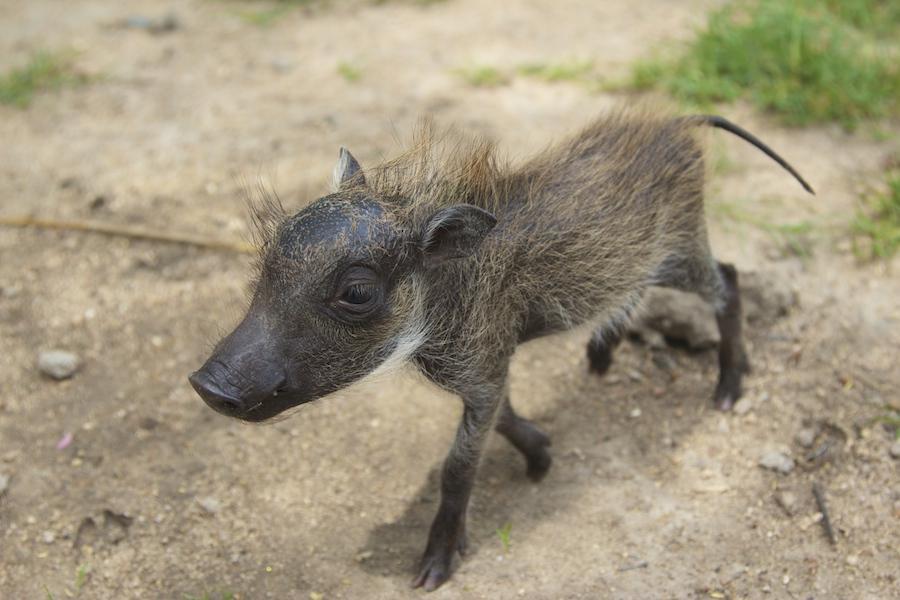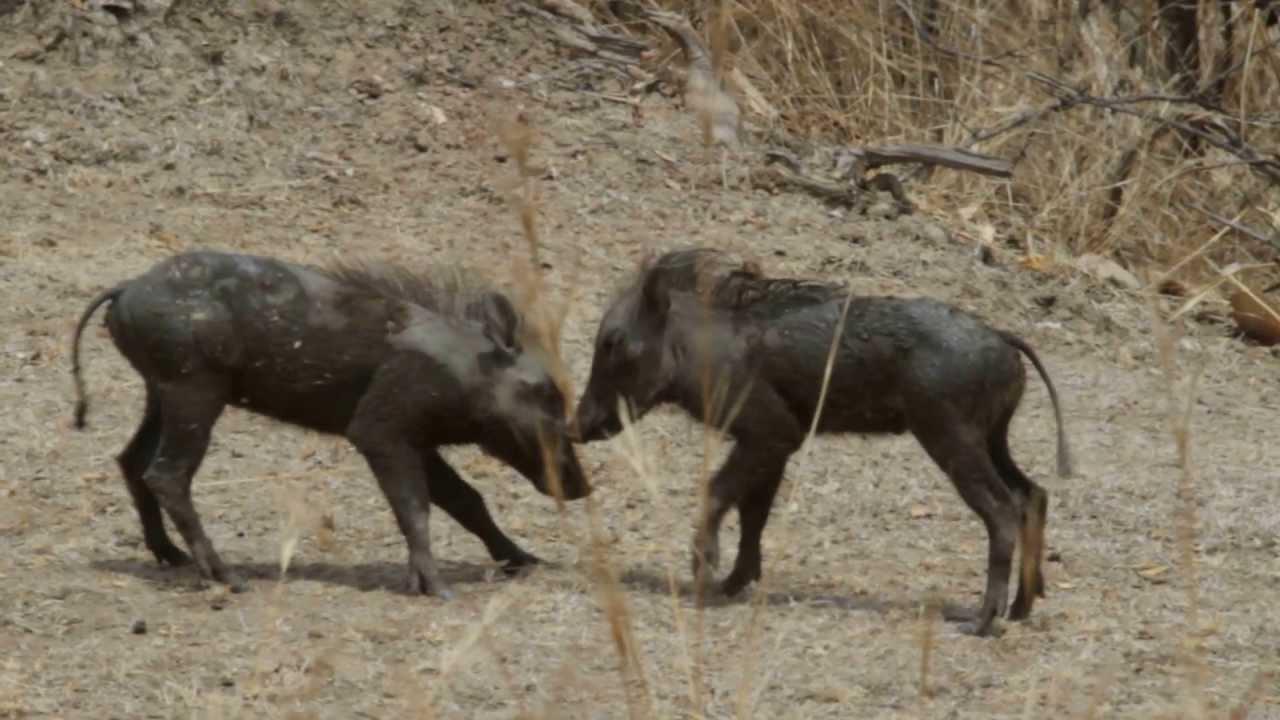The first image is the image on the left, the second image is the image on the right. Considering the images on both sides, is "There are two hogs facing each other in one of the images." valid? Answer yes or no. Yes. The first image is the image on the left, the second image is the image on the right. Assess this claim about the two images: "The lefthand image contains one young warthog, and the righthand image contains two young warthogs.". Correct or not? Answer yes or no. Yes. 